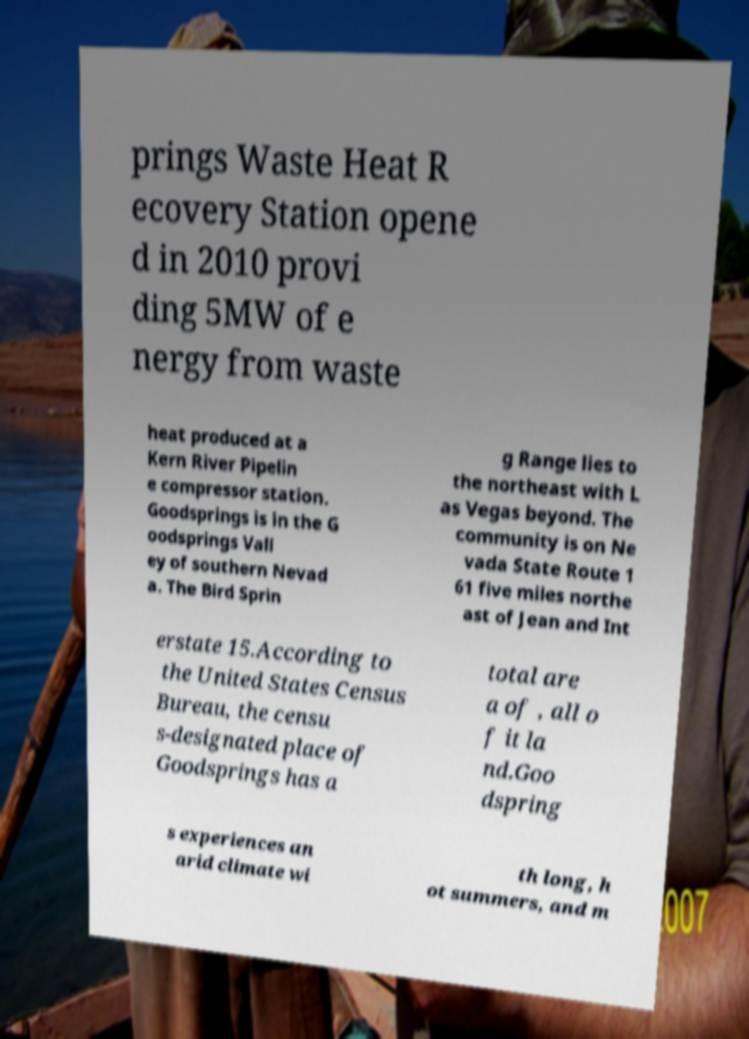Please identify and transcribe the text found in this image. prings Waste Heat R ecovery Station opene d in 2010 provi ding 5MW of e nergy from waste heat produced at a Kern River Pipelin e compressor station. Goodsprings is in the G oodsprings Vall ey of southern Nevad a. The Bird Sprin g Range lies to the northeast with L as Vegas beyond. The community is on Ne vada State Route 1 61 five miles northe ast of Jean and Int erstate 15.According to the United States Census Bureau, the censu s-designated place of Goodsprings has a total are a of , all o f it la nd.Goo dspring s experiences an arid climate wi th long, h ot summers, and m 